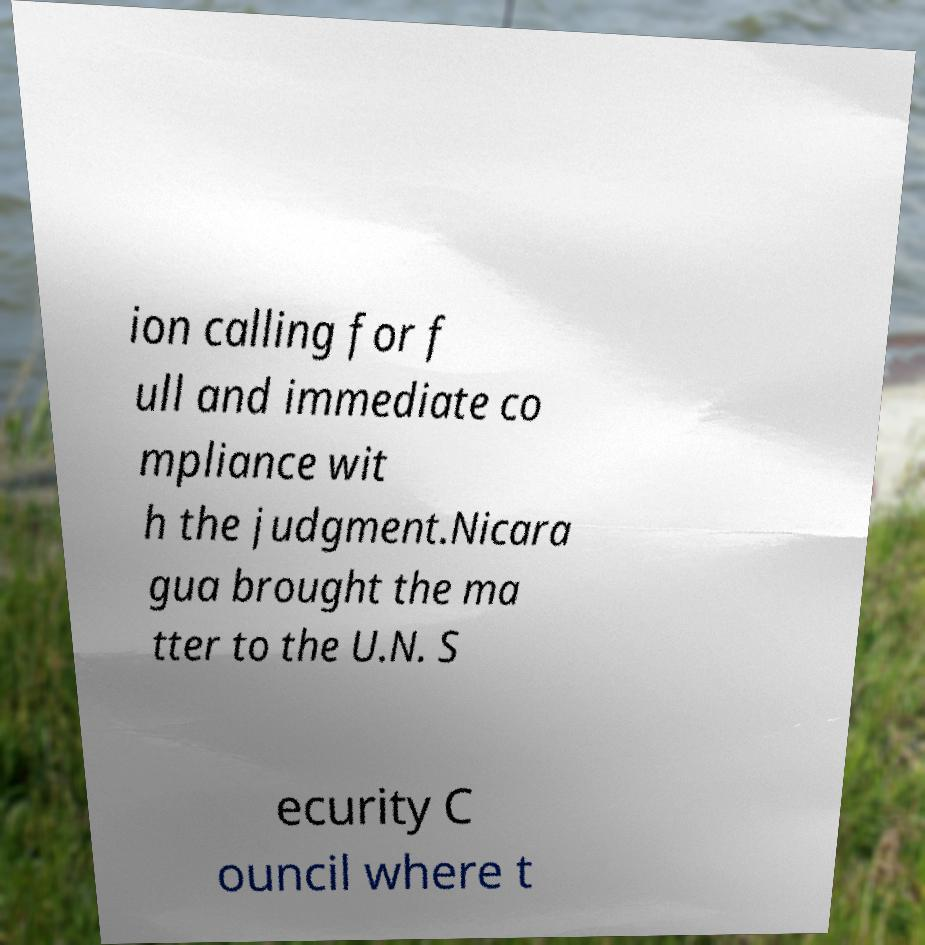Please read and relay the text visible in this image. What does it say? ion calling for f ull and immediate co mpliance wit h the judgment.Nicara gua brought the ma tter to the U.N. S ecurity C ouncil where t 